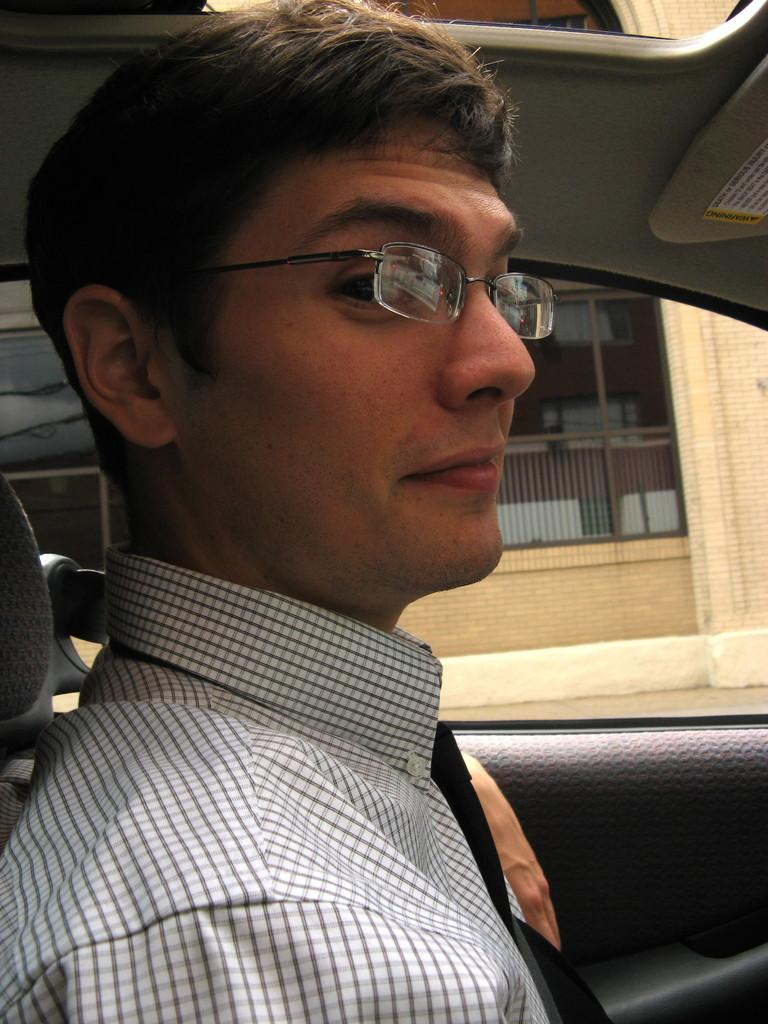Who is present in the image? There is a man in the image. What is the man doing in the image? The man is sitting inside a vehicle. Can you describe the man's appearance in the image? The man is wearing spectacles. What type of bike can be seen in the image? There is no bike present in the image. What time of day is it in the image, considering it's an afternoon scene? The time of day cannot be determined from the image, as there are no specific details about the lighting or time of day. 